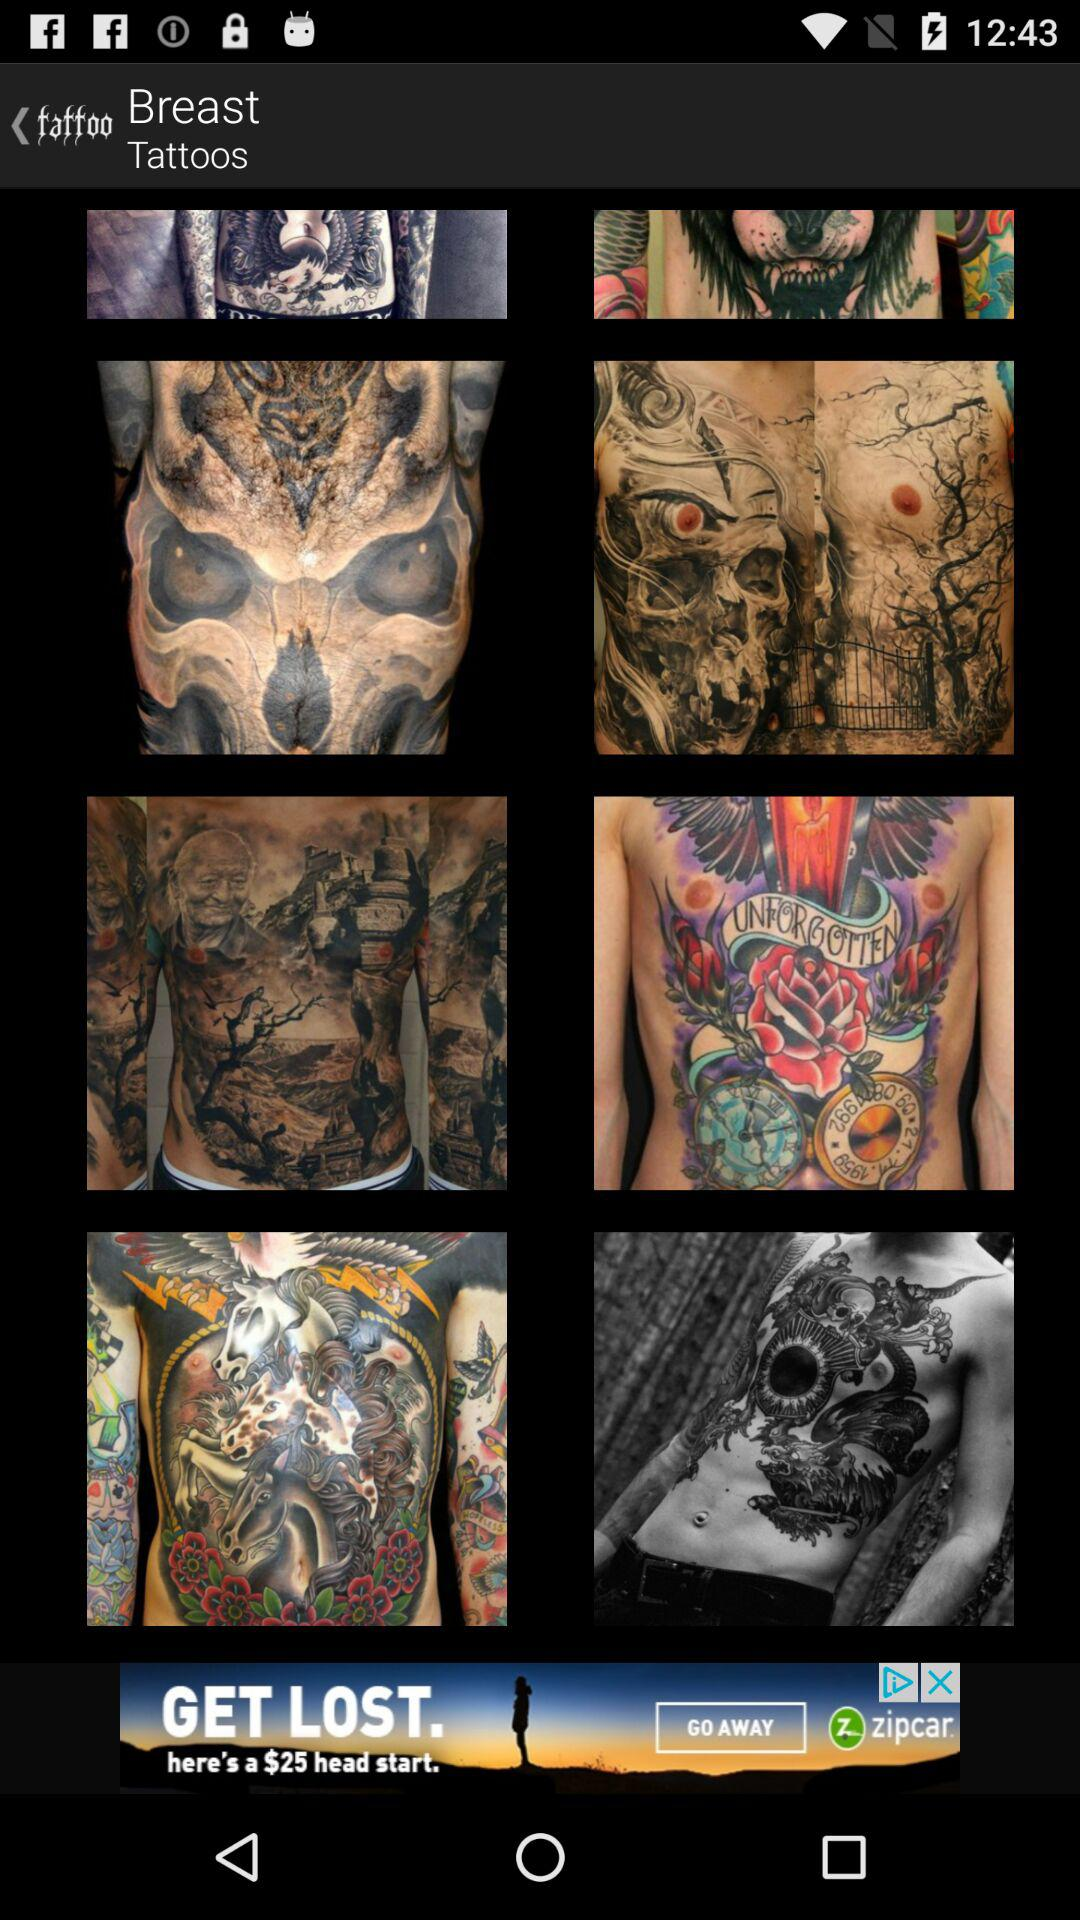What type of tattoos are shown? The tattoos shown are of the breast type. 